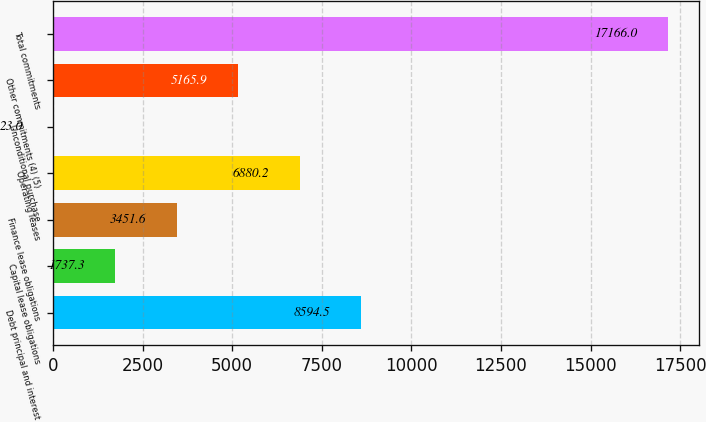<chart> <loc_0><loc_0><loc_500><loc_500><bar_chart><fcel>Debt principal and interest<fcel>Capital lease obligations<fcel>Finance lease obligations<fcel>Operating leases<fcel>Unconditional purchase<fcel>Other commitments (4) (5)<fcel>Total commitments<nl><fcel>8594.5<fcel>1737.3<fcel>3451.6<fcel>6880.2<fcel>23<fcel>5165.9<fcel>17166<nl></chart> 